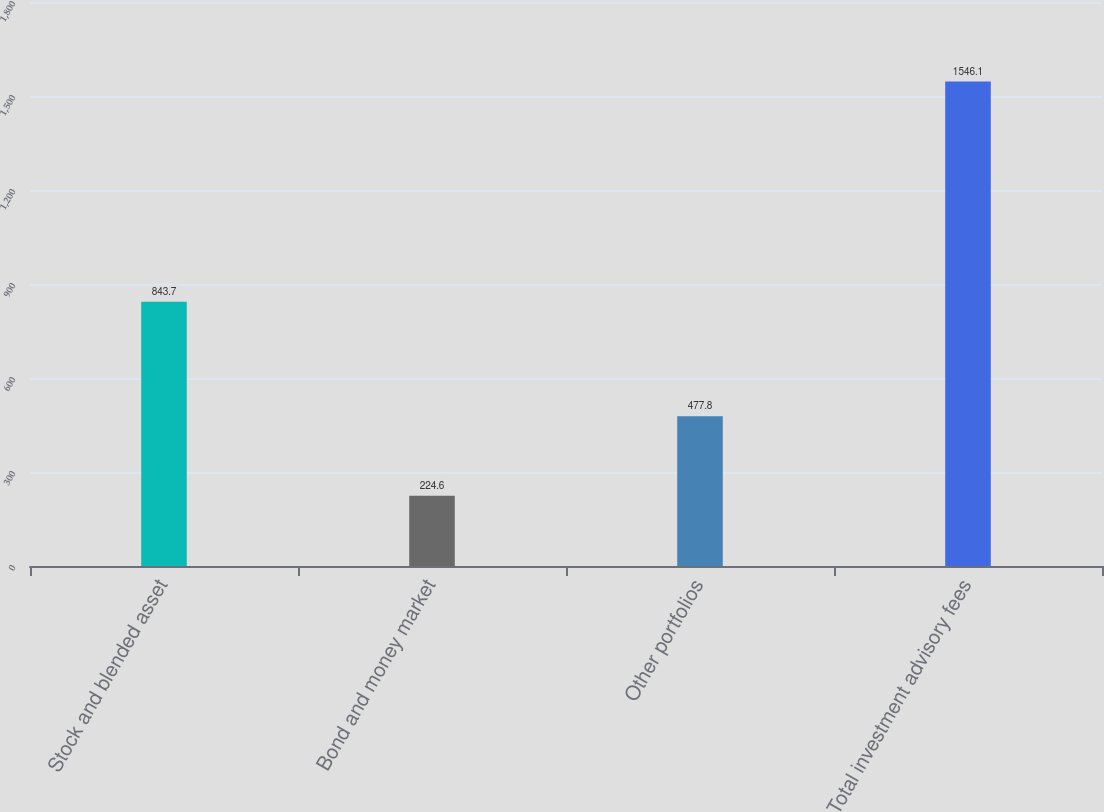Convert chart. <chart><loc_0><loc_0><loc_500><loc_500><bar_chart><fcel>Stock and blended asset<fcel>Bond and money market<fcel>Other portfolios<fcel>Total investment advisory fees<nl><fcel>843.7<fcel>224.6<fcel>477.8<fcel>1546.1<nl></chart> 